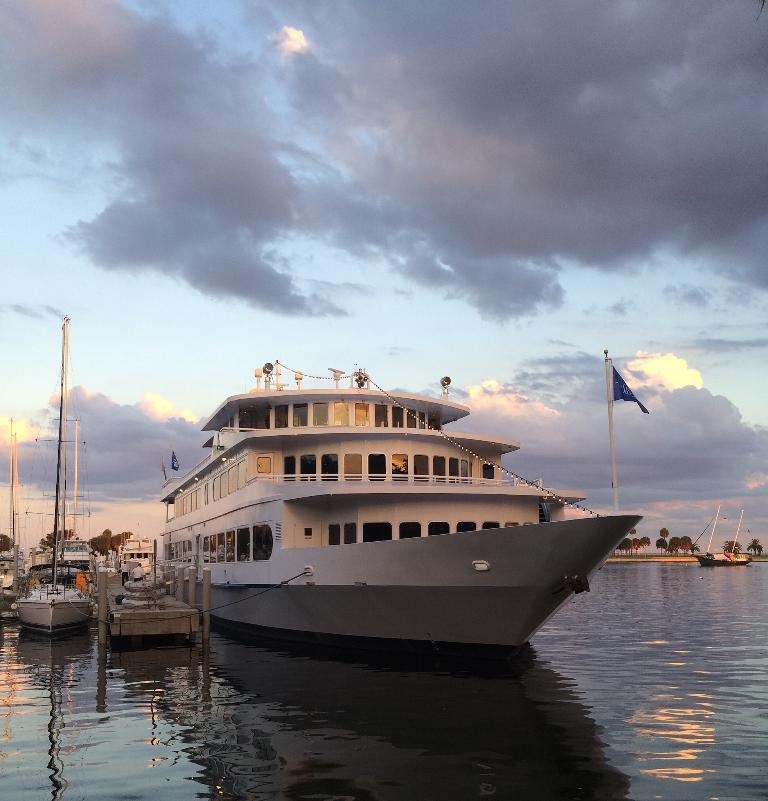What is the main subject in the middle of the image? There is a boat in the middle of the image. What can be seen on the right side of the image? There are trees, a flag, and a pole on the right side of the image. What is visible on the left side of the image? There are boats and waves on the left side of the image. What is the background of the image? The sky is visible in the background of the image, with clouds present. What type of pie is being served on the boat in the image? There is no pie present in the image; it features a boat, trees, a flag, a pole, boats, waves, the sky, and clouds. 